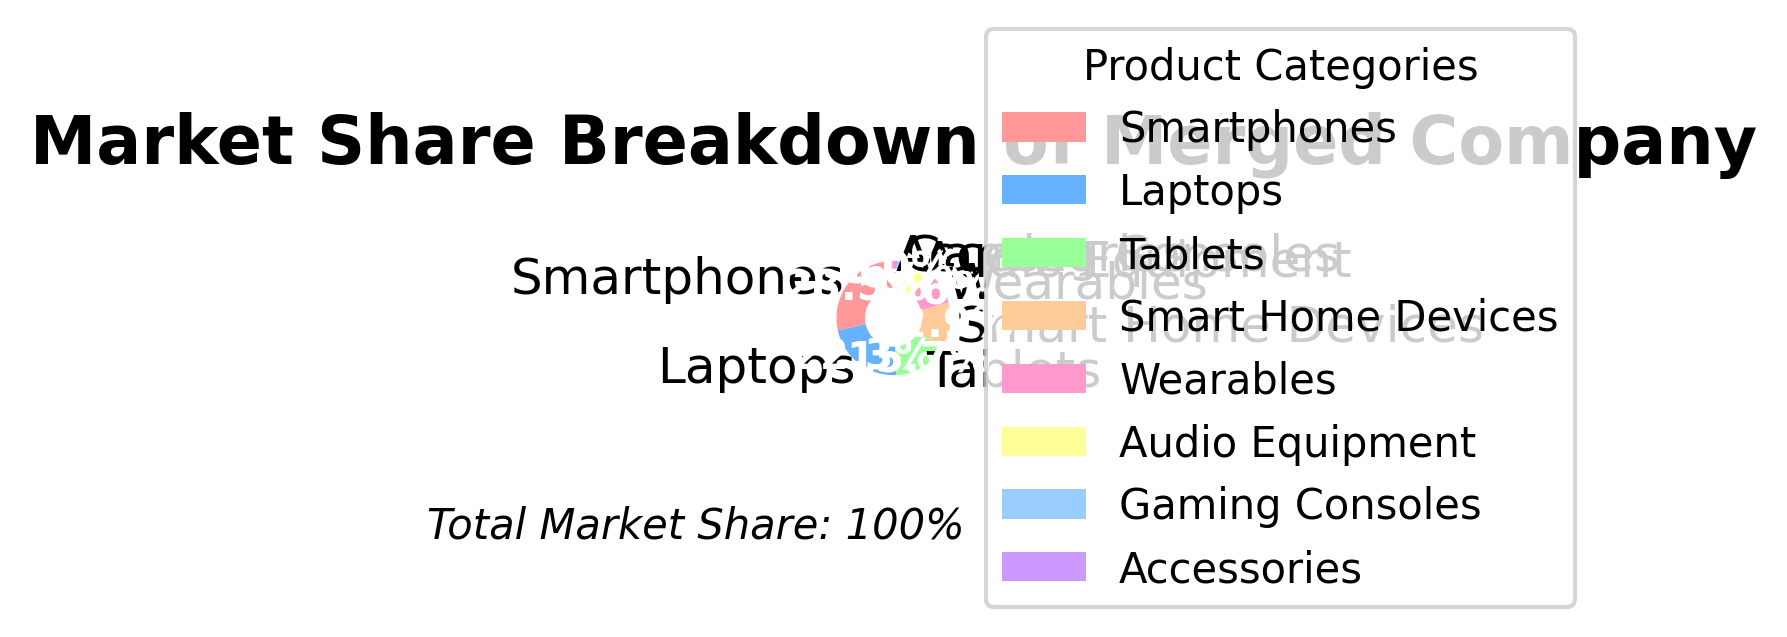Which product category has the largest market share? The largest segment in the pie chart corresponds to Smartphones, which accounts for 28.5% of the market share.
Answer: Smartphones Which product category has the smallest market share? The smallest segment in the pie chart corresponds to Accessories, which accounts for 1.0% of the market share.
Answer: Accessories Which two product categories combined have a market share greater than or equal to 50%? Combining Smartphones (28.5%) and Laptops (22.3%), the total market share is 28.5% + 22.3% = 50.8%, which exceeds 50%.
Answer: Smartphones and Laptops What is the market share difference between Smartphones and Laptops? The market share of Smartphones is 28.5% and that of Laptops is 22.3%. The difference is 28.5% - 22.3% = 6.2%.
Answer: 6.2% Which products together make up more than 75% of the market share? Summing the market shares: Smartphones (28.5%), Laptops (22.3%), Tablets (15.7%), and Smart Home Devices (12.9%) results in 28.5% + 22.3% + 15.7% + 12.9% = 79.4%, exceeding 75%.
Answer: Smartphones, Laptops, Tablets, and Smart Home Devices Which segment is represented by the blue color in the pie chart? The order from the code indicates the second segment is represented by blue, corresponding to Laptops.
Answer: Laptops What percentage of the market share is held by Wearables and Audio Equipment combined? Adding the market shares of Wearables (9.6%) and Audio Equipment (6.8%) results in 9.6% + 6.8% = 16.4%.
Answer: 16.4% Is the market share of Audio Equipment greater than that of Gaming Consoles? The market share of Audio Equipment is 6.8%, while that of Gaming Consoles is 3.2%, so Audio Equipment has a greater market share.
Answer: Yes How does the market share of Smart Home Devices compare to Tablets? The market share of Smart Home Devices is 12.9%, while Tablets have 15.7%. Therefore, Tablets have a larger market share.
Answer: Tablets have a larger market share What is the combined market share of the bottom three product categories? Summing the market shares of Audio Equipment (6.8%), Gaming Consoles (3.2%), and Accessories (1.0%) results in 6.8% + 3.2% + 1.0% = 11.0%.
Answer: 11.0% 